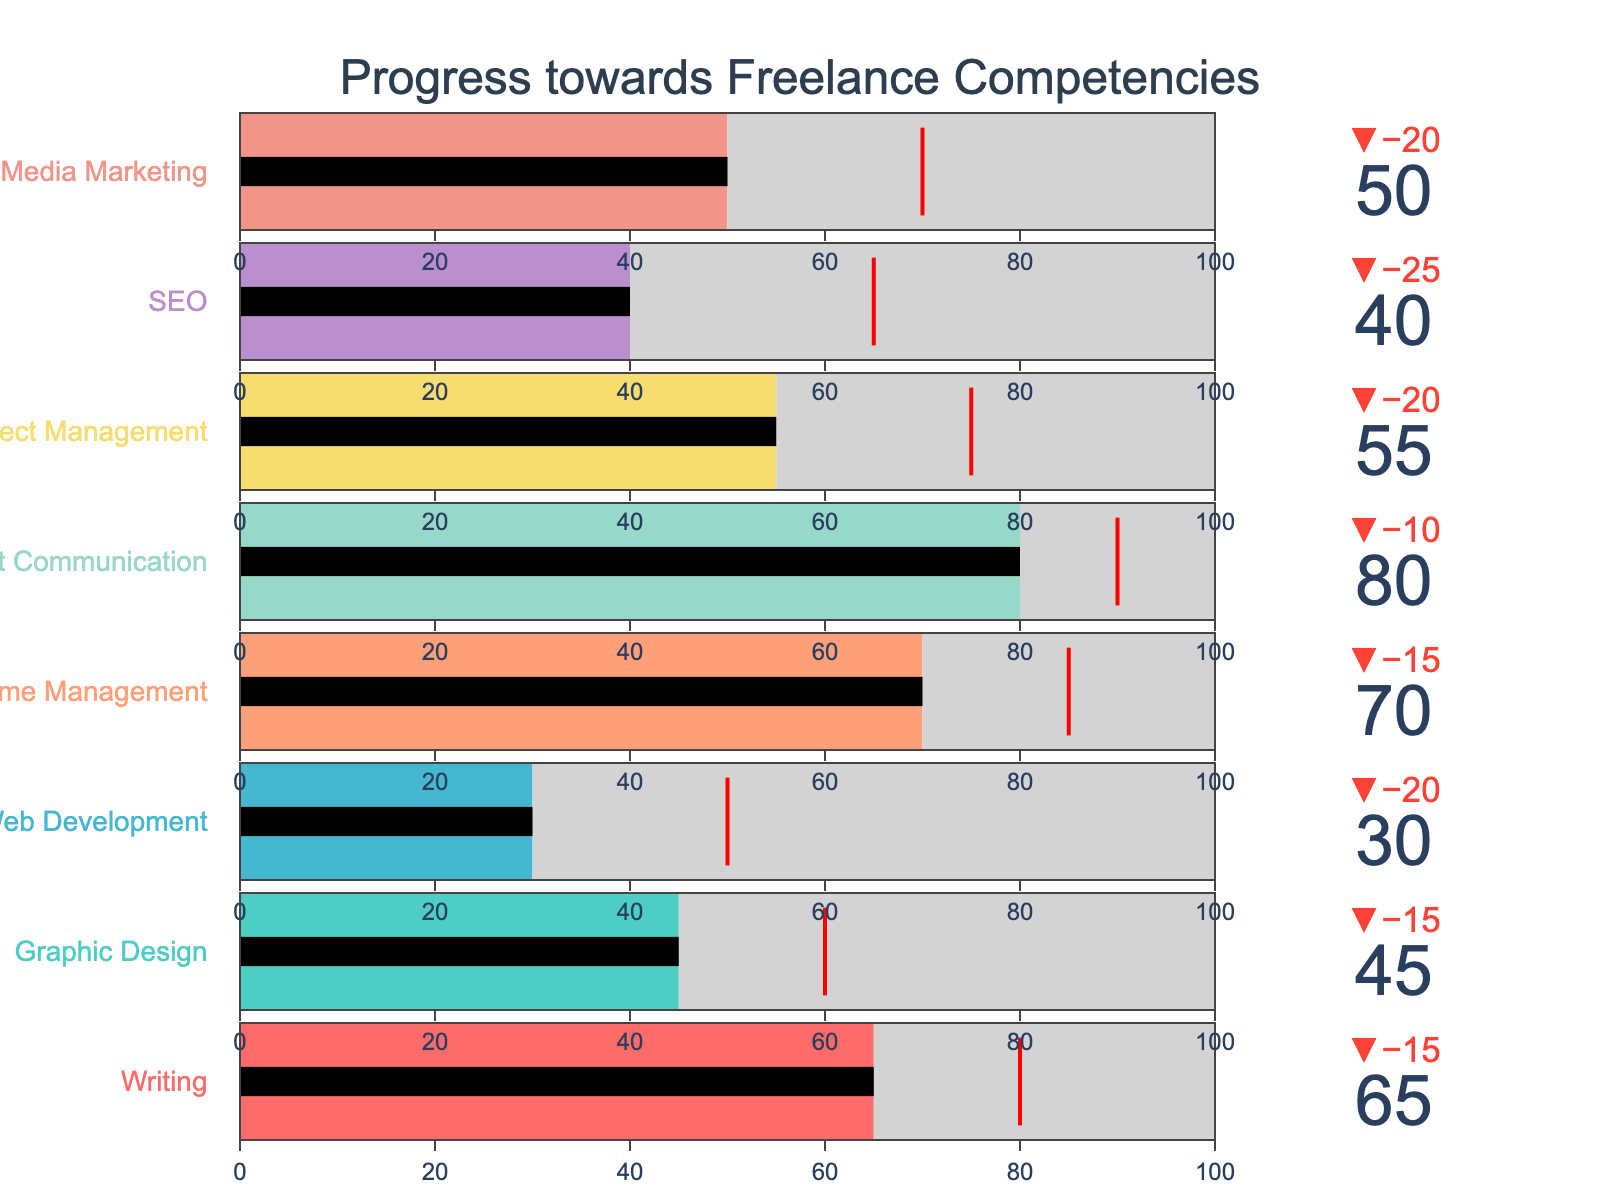What is the highest value among the "Actual" measurements? The "Actual" measurement represents the current level of skill achieved. In the figure, the "Client Communication" skill has an "Actual" value of 80, which is the highest among all skills listed.
Answer: 80 Which skill has the largest gap between the "Actual" and the "Target"? To determine the largest gap, subtract the "Actual" value from the "Target" value for each skill and find the maximum difference. The gap for each skill are: Writing (15), Graphic Design (15), Web Development (20), Time Management (15), Client Communication (10), Project Management (20), SEO (25), Social Media Marketing (20). "SEO" shows the largest gap of 25.
Answer: SEO What is the "Target" value for "Graphic Design"? The "Target" value is explicitly shown for each skill. For "Graphic Design," the figure shows a "Target" of 60.
Answer: 60 Which skill has the lowest "Actual" value? The "Actual" values represent the current performance level for each skill. "Web Development" has the lowest "Actual" value at 30.
Answer: Web Development How many skills have "Actual" values that exceed 50? Count the number of skills where the "Actual" value is greater than 50. The skills are: Writing (65), Time Management (70), Client Communication (80), and Social Media Marketing (50). Therefore, there are three skills where the "Actual" value exceeds 50.
Answer: 4 What is the average "Target" value for all skills? Sum all the "Target" values and divide by the number of skills: (80 + 60 + 50 + 85 + 90 + 75 + 65 + 70)/8. This equals (575/8) = 71.875
Answer: 71.875 What is the threshold color used to indicate "Target" points? The threshold color is represented by lines that mark the "Target" levels for each skill. The color for the threshold is red.
Answer: Red 